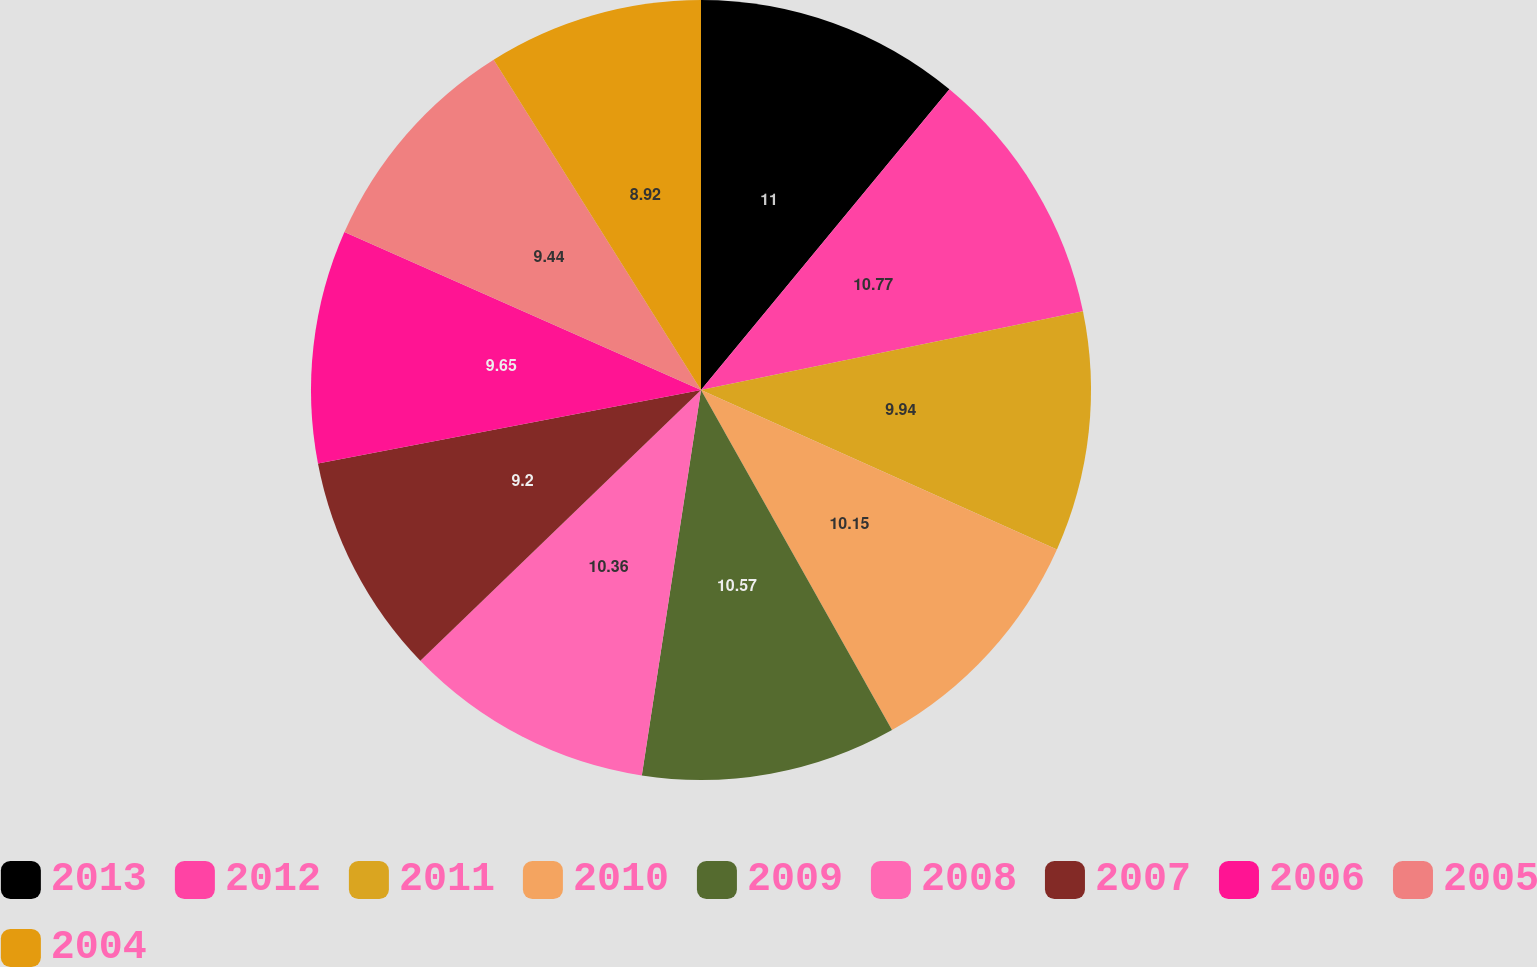Convert chart to OTSL. <chart><loc_0><loc_0><loc_500><loc_500><pie_chart><fcel>2013<fcel>2012<fcel>2011<fcel>2010<fcel>2009<fcel>2008<fcel>2007<fcel>2006<fcel>2005<fcel>2004<nl><fcel>10.99%<fcel>10.77%<fcel>9.94%<fcel>10.15%<fcel>10.57%<fcel>10.36%<fcel>9.2%<fcel>9.65%<fcel>9.44%<fcel>8.92%<nl></chart> 